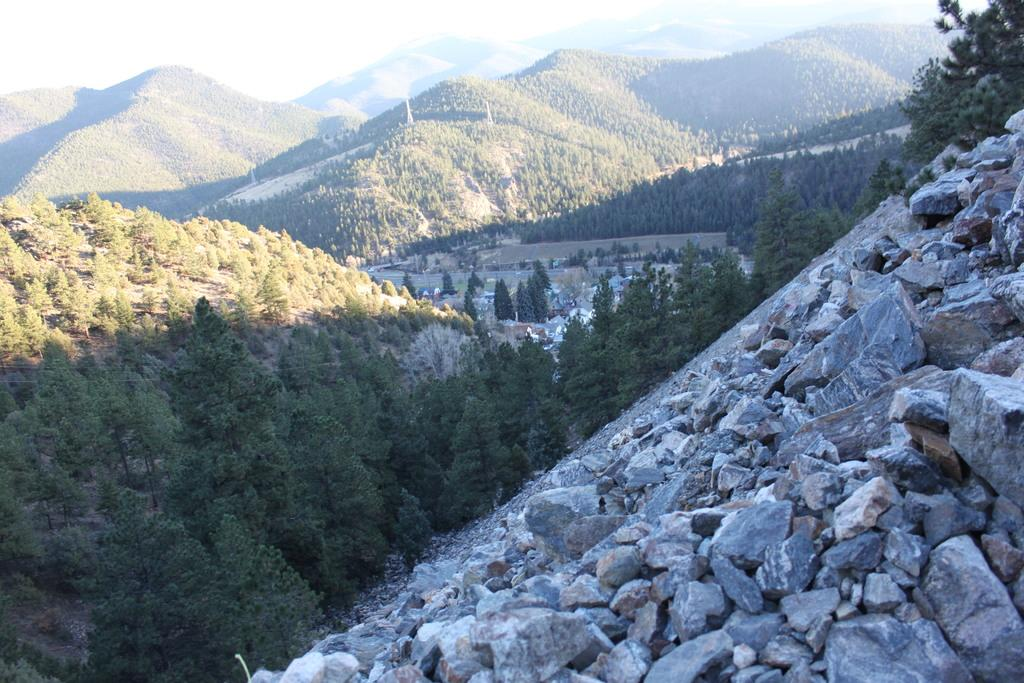What type of natural formation can be seen in the image? There are mountains in the image. What type of structures are present in the image? There are houses and towers in the image. What can be seen in the sky in the image? The sky is visible in the image, and sunlight is present. What type of hose is being used by the jellyfish in the image? There are no jellyfish or hoses present in the image. What language is spoken by the people in the image? The image does not depict any people or provide any information about spoken languages. 